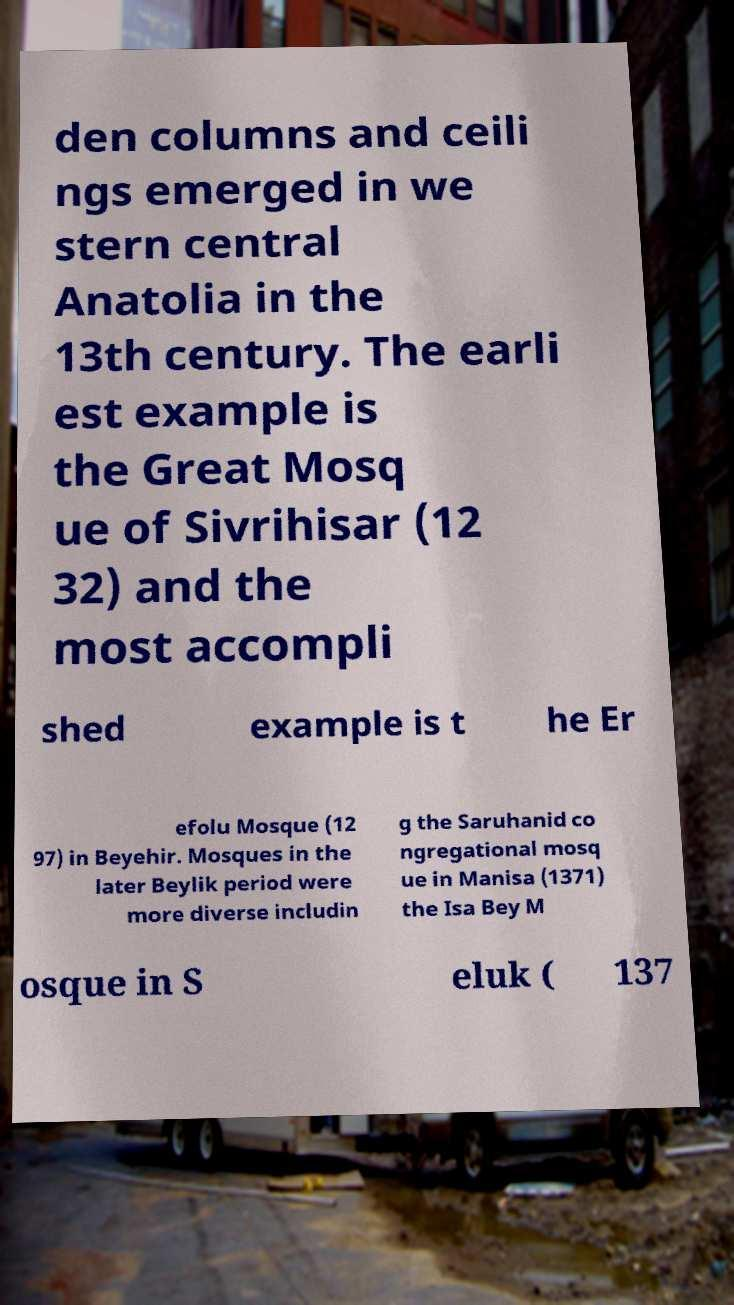Please identify and transcribe the text found in this image. den columns and ceili ngs emerged in we stern central Anatolia in the 13th century. The earli est example is the Great Mosq ue of Sivrihisar (12 32) and the most accompli shed example is t he Er efolu Mosque (12 97) in Beyehir. Mosques in the later Beylik period were more diverse includin g the Saruhanid co ngregational mosq ue in Manisa (1371) the Isa Bey M osque in S eluk ( 137 